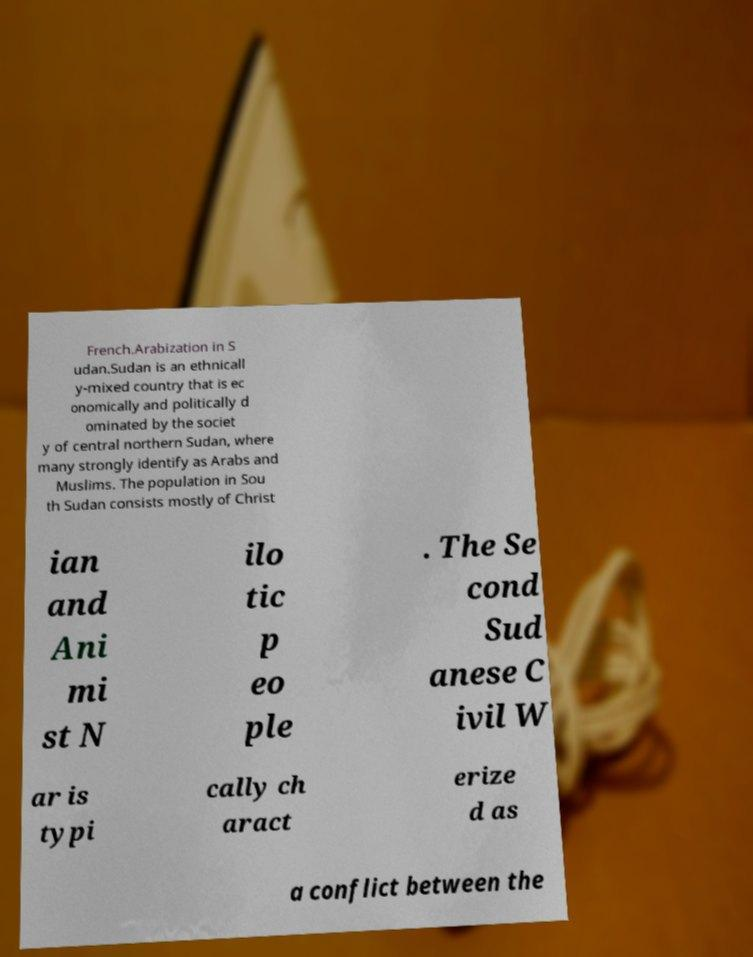Could you extract and type out the text from this image? French.Arabization in S udan.Sudan is an ethnicall y-mixed country that is ec onomically and politically d ominated by the societ y of central northern Sudan, where many strongly identify as Arabs and Muslims. The population in Sou th Sudan consists mostly of Christ ian and Ani mi st N ilo tic p eo ple . The Se cond Sud anese C ivil W ar is typi cally ch aract erize d as a conflict between the 